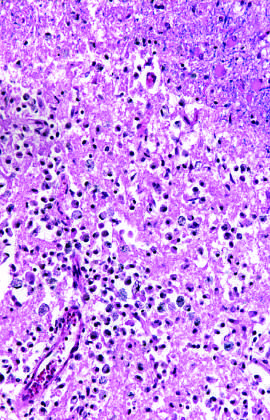does the distal edge of the intramural hematoma show the presence of macrophages and surrounding reactive gliosis by day 10?
Answer the question using a single word or phrase. No 